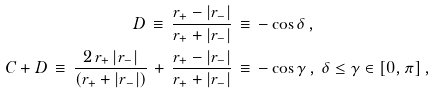<formula> <loc_0><loc_0><loc_500><loc_500>D \, \equiv \, \frac { r _ { + } - | r _ { - } | } { r _ { + } + | r _ { - } | } \, & \equiv \, - \cos \delta \, , \\ C + D \, \equiv \, \frac { 2 \, r _ { + } \, | r _ { - } | } { ( r _ { + } + | r _ { - } | ) } \, + \, \frac { r _ { + } - | r _ { - } | } { r _ { + } + | r _ { - } | } \, & \equiv \, - \cos \gamma \, , \, \delta \leq \gamma \in [ 0 , \pi ] \, ,</formula> 